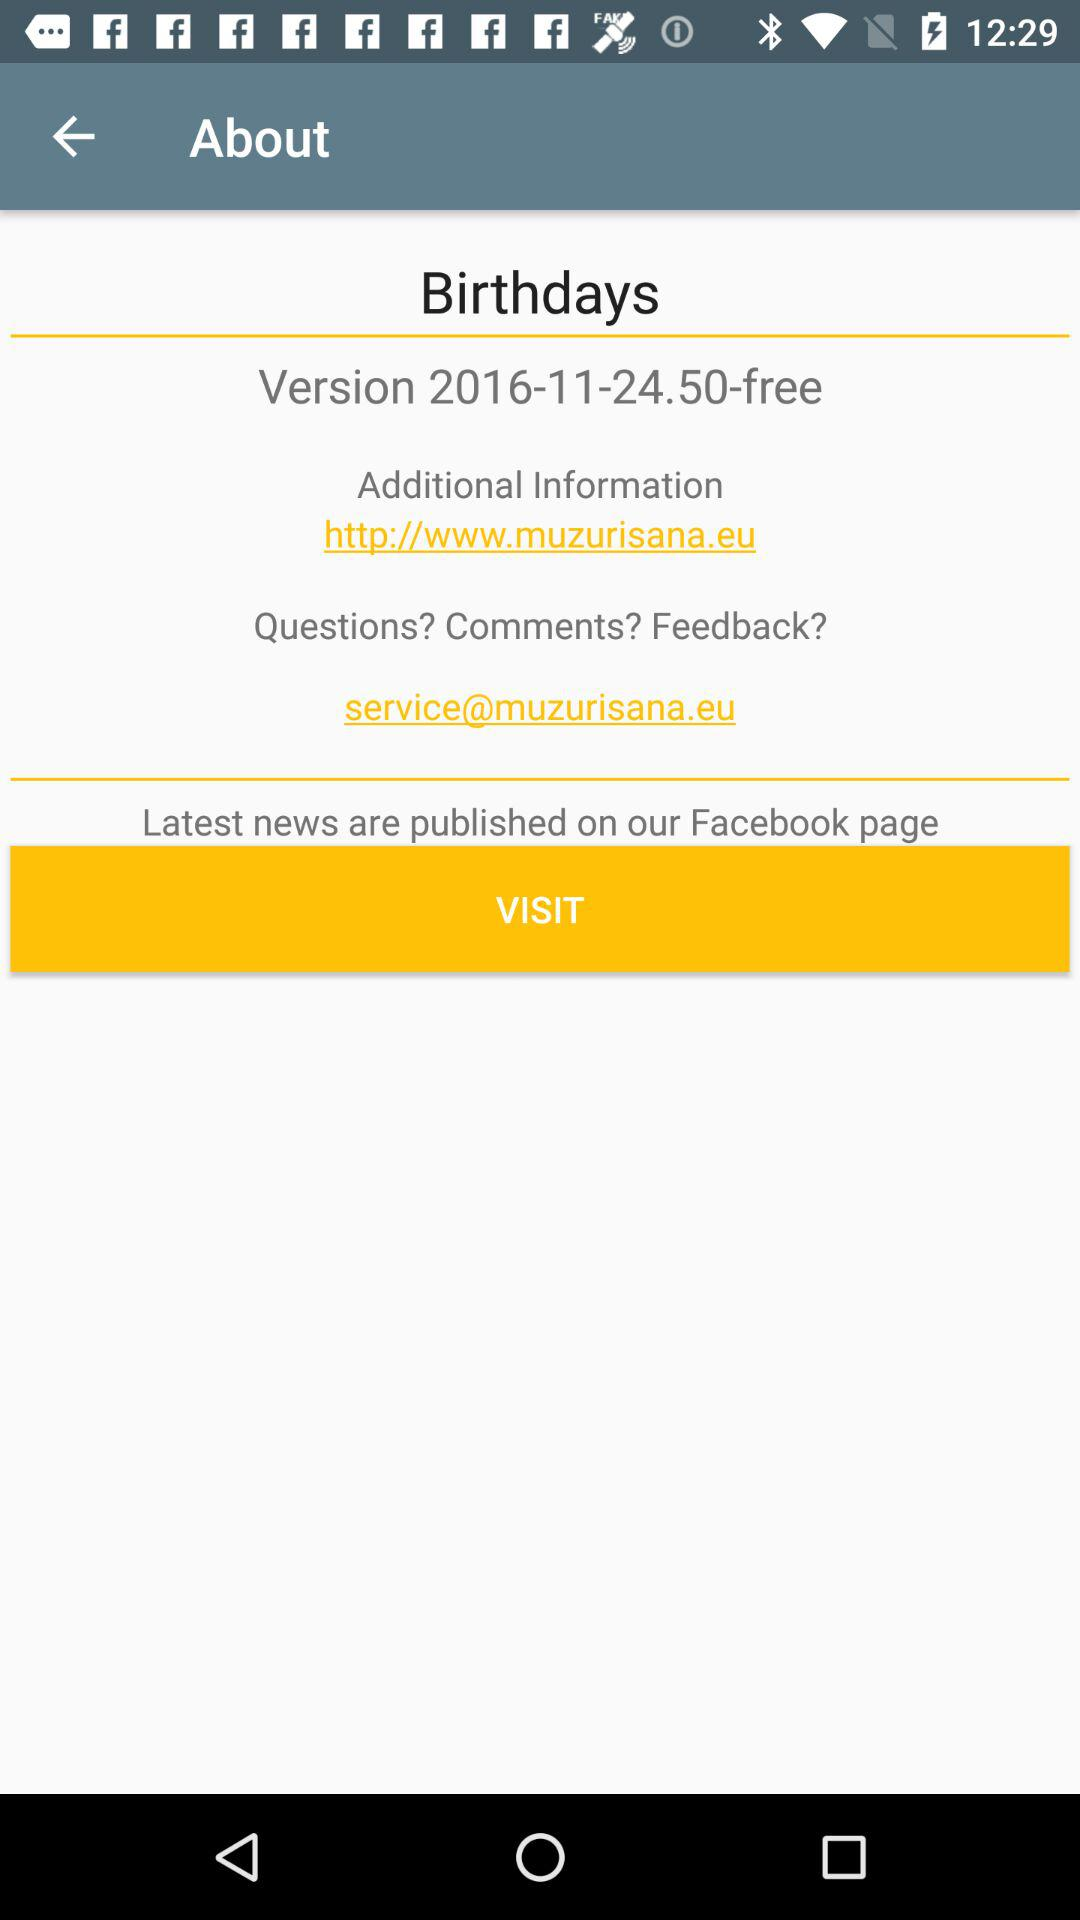What is the email address for comments and feedback? The email address is service@muzurisana.eu. 